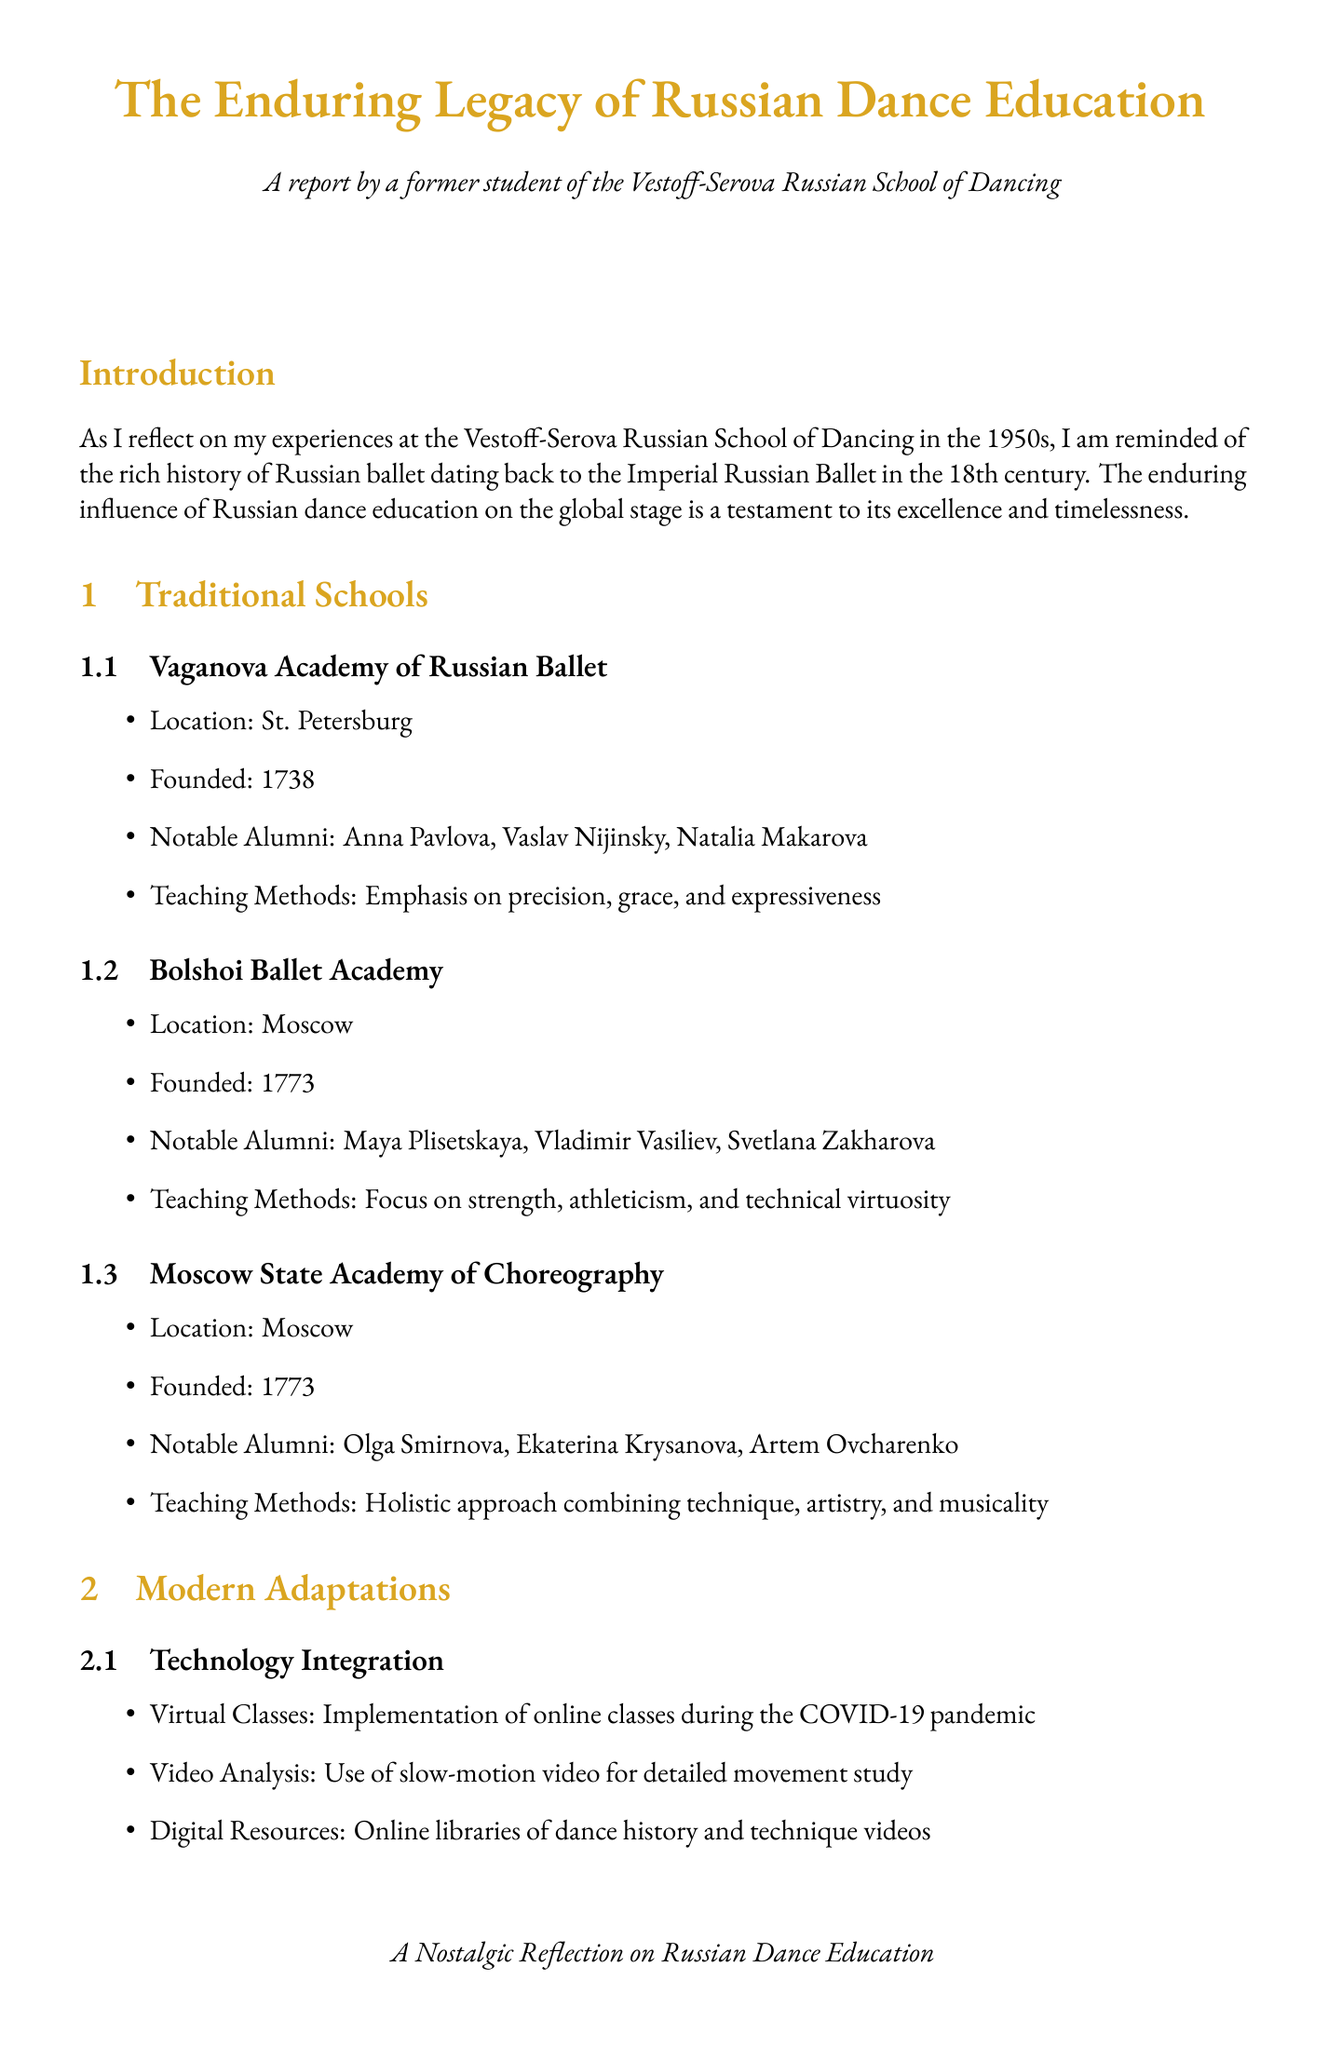What is the founding year of the Vaganova Academy? The founding year of the Vaganova Academy is provided in the document, which is 1738.
Answer: 1738 Who is a notable alumnus of the Bolshoi Ballet Academy? The document lists notable alumni from the Bolshoi Ballet Academy, including Maya Plisetskaya.
Answer: Maya Plisetskaya What teaching method is emphasized by the Moscow State Academy of Choreography? The teaching method emphasized by this academy is detailed in the document as a holistic approach combining technique, artistry, and musicality.
Answer: Holistic approach What modern adaptation was implemented during the COVID-19 pandemic? The document specifies that online classes were implemented during the pandemic as a modern adaptation.
Answer: Online classes What is one challenge mentioned regarding dance education in Russia? The document lists several challenges, one of which is decreased government support for arts education.
Answer: Decreased government support Which international ballet company is mentioned in the exchange programs? The document mentions partnerships with American Ballet Theatre in the context of international collaborations.
Answer: American Ballet Theatre What is the status of Diana Vishneva according to the success stories? The document states that Diana Vishneva is a principal dancer with Mariinsky Ballet and American Ballet Theatre.
Answer: Principal dancer What future focus is highlighted for the preservation of dance tradition? The document states that maintaining the core principles of Russian classical ballet is a focus for the future.
Answer: Core principles Who is the youngest principal dancer in Royal Ballet history? The document identifies Sergei Polunin as the youngest principal dancer in Royal Ballet history.
Answer: Sergei Polunin 